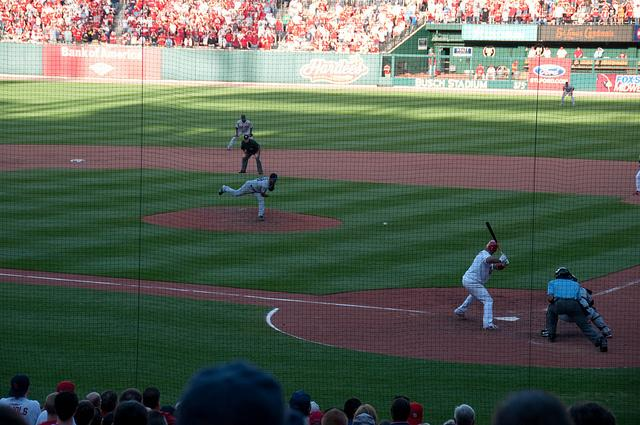What play is the best case scenario for the batter? Please explain your reasoning. home run. The best hit a batter can get is hitting it out of the park, which is called a home run. 